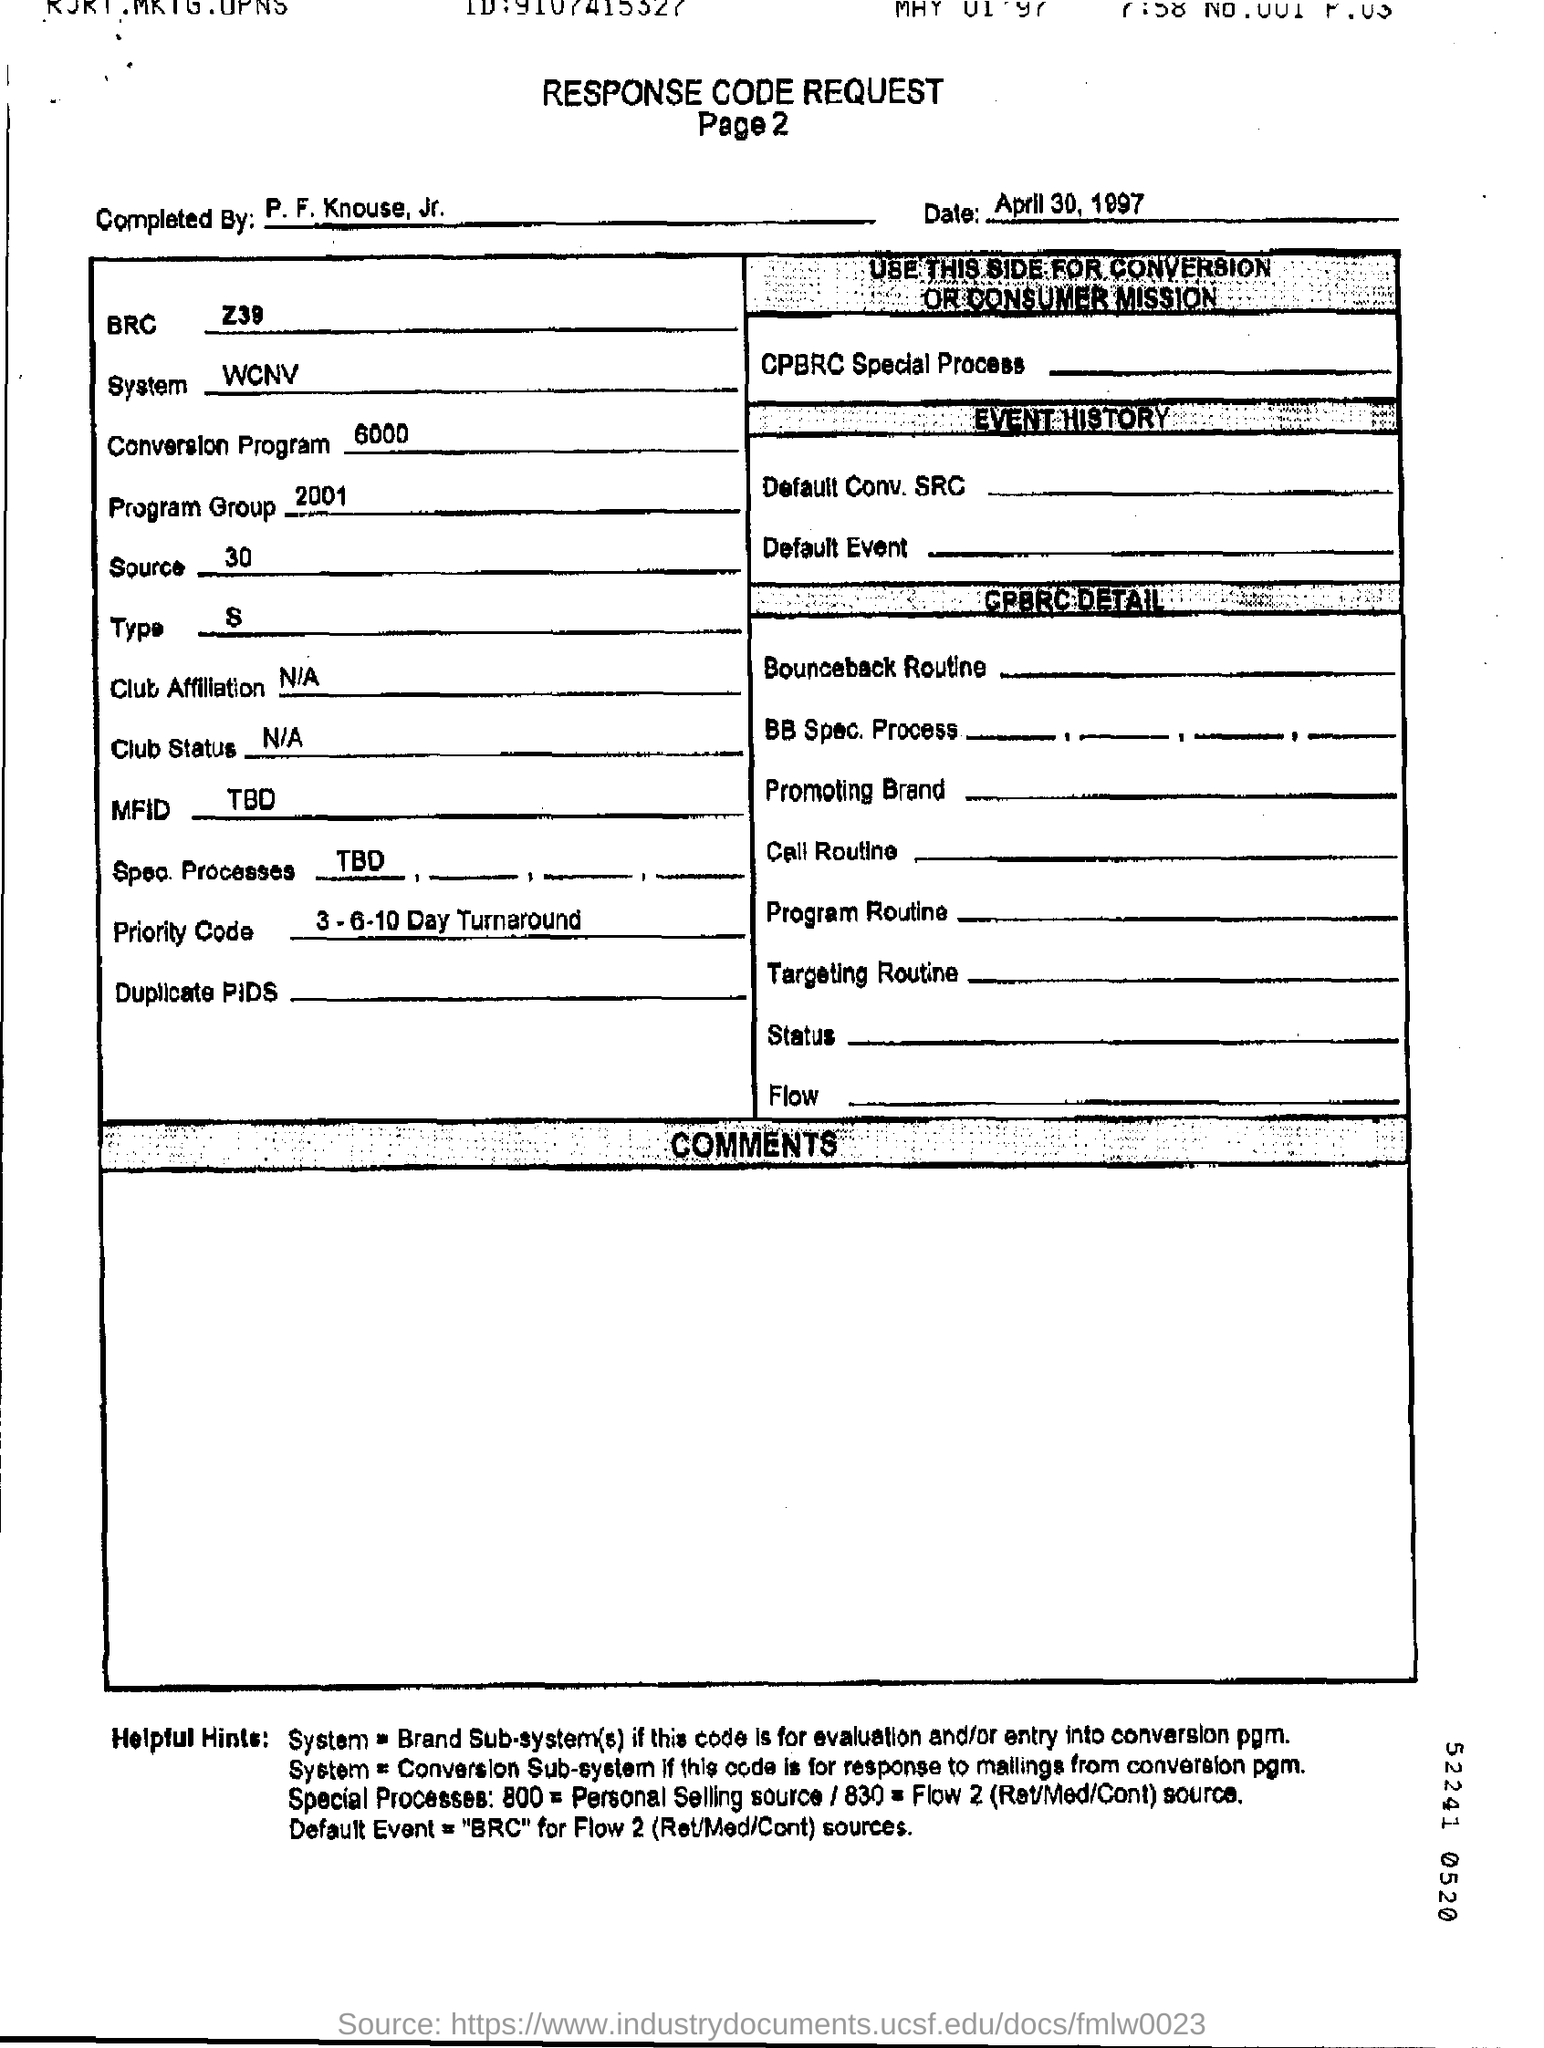List a handful of essential elements in this visual. The completion of the work "Who Is It?" was completed by P. F. Knouse, Jr. What is the source of the number 30? The system is WCNV. The Conversion program is a 6000-word text that provides information about a specific topic. The date is April 30, 1997. 